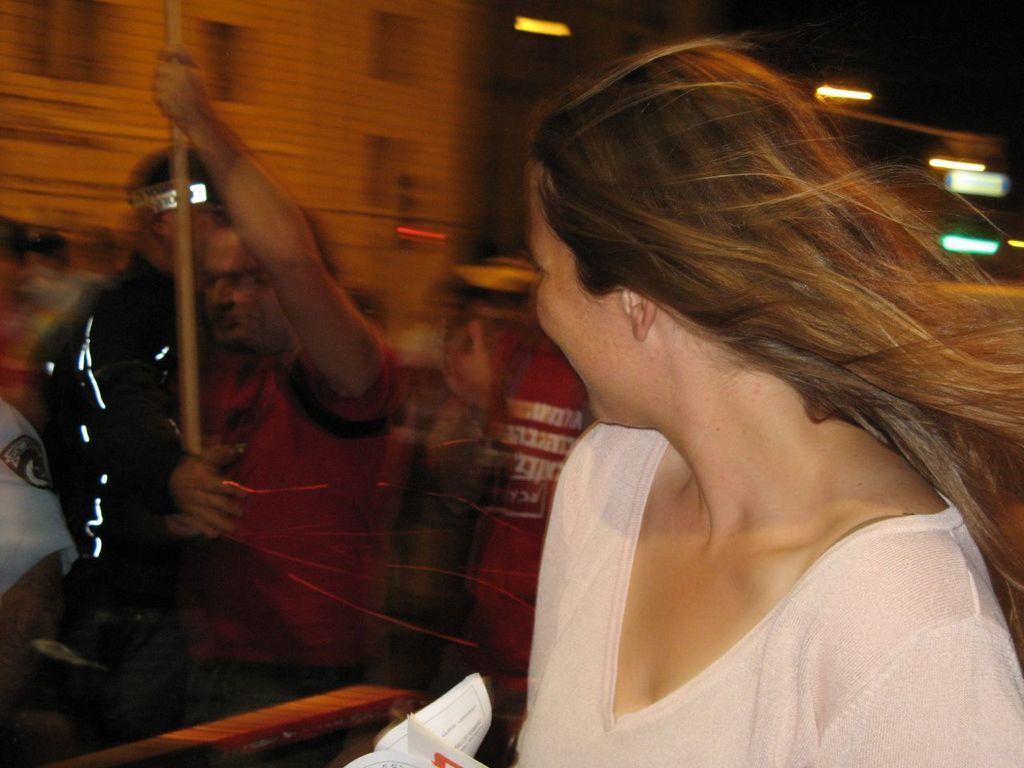Could you give a brief overview of what you see in this image? In this image there is a person , and in the background there are group of people and a building. 